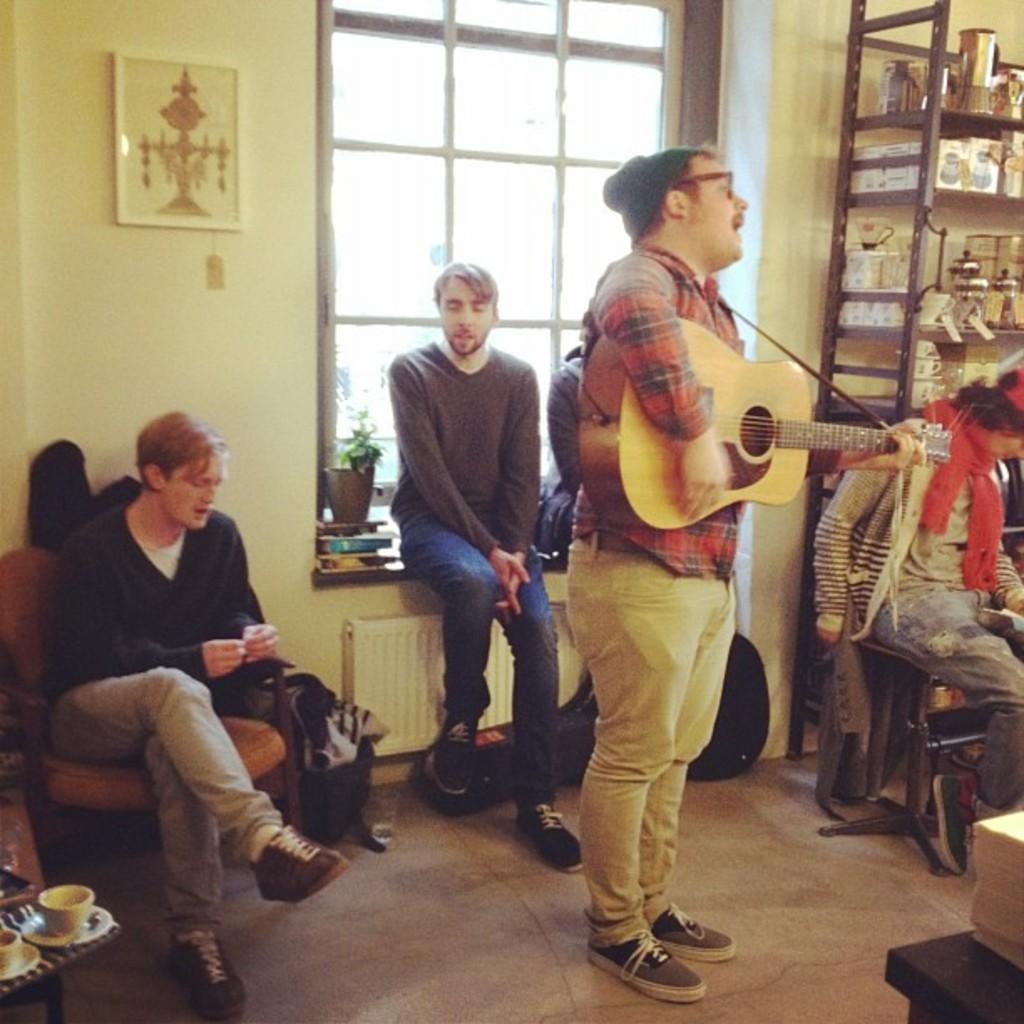Describe this image in one or two sentences. The image is inside a room there are group of people in the room , one person is standing and playing guitar he is also singing,to his right side there is an almirah and few utensils in the background there is a window and also a wall. 